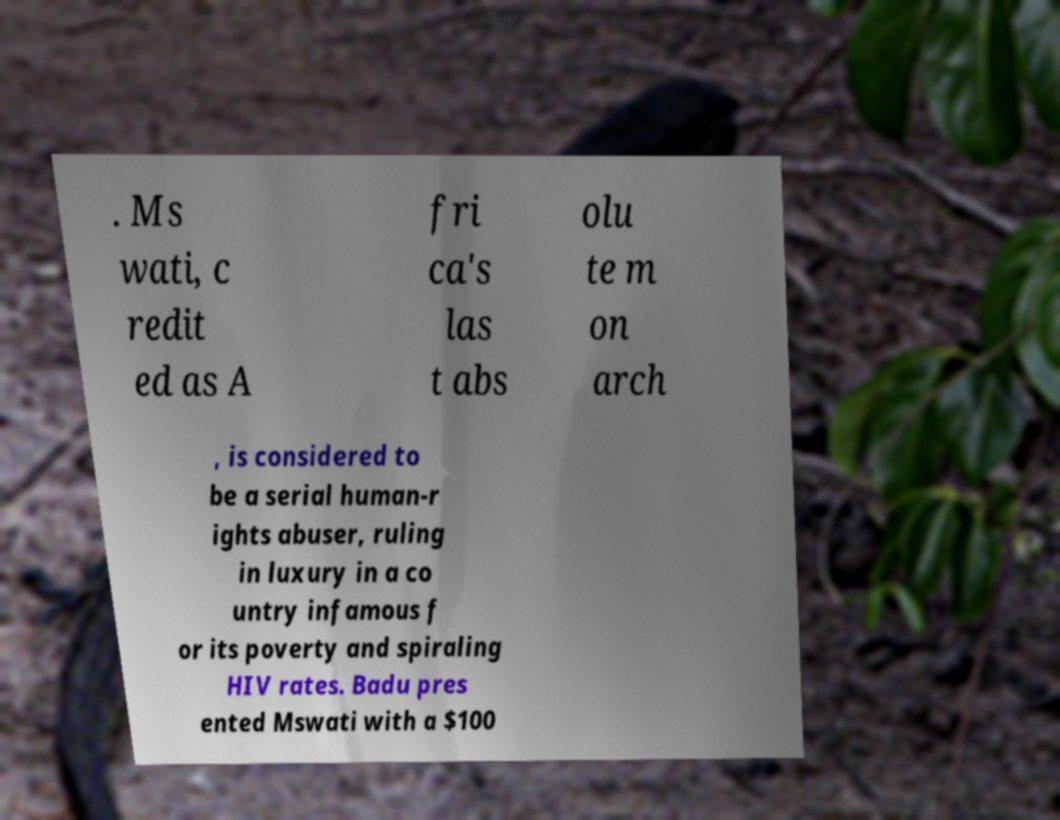Please identify and transcribe the text found in this image. . Ms wati, c redit ed as A fri ca's las t abs olu te m on arch , is considered to be a serial human-r ights abuser, ruling in luxury in a co untry infamous f or its poverty and spiraling HIV rates. Badu pres ented Mswati with a $100 